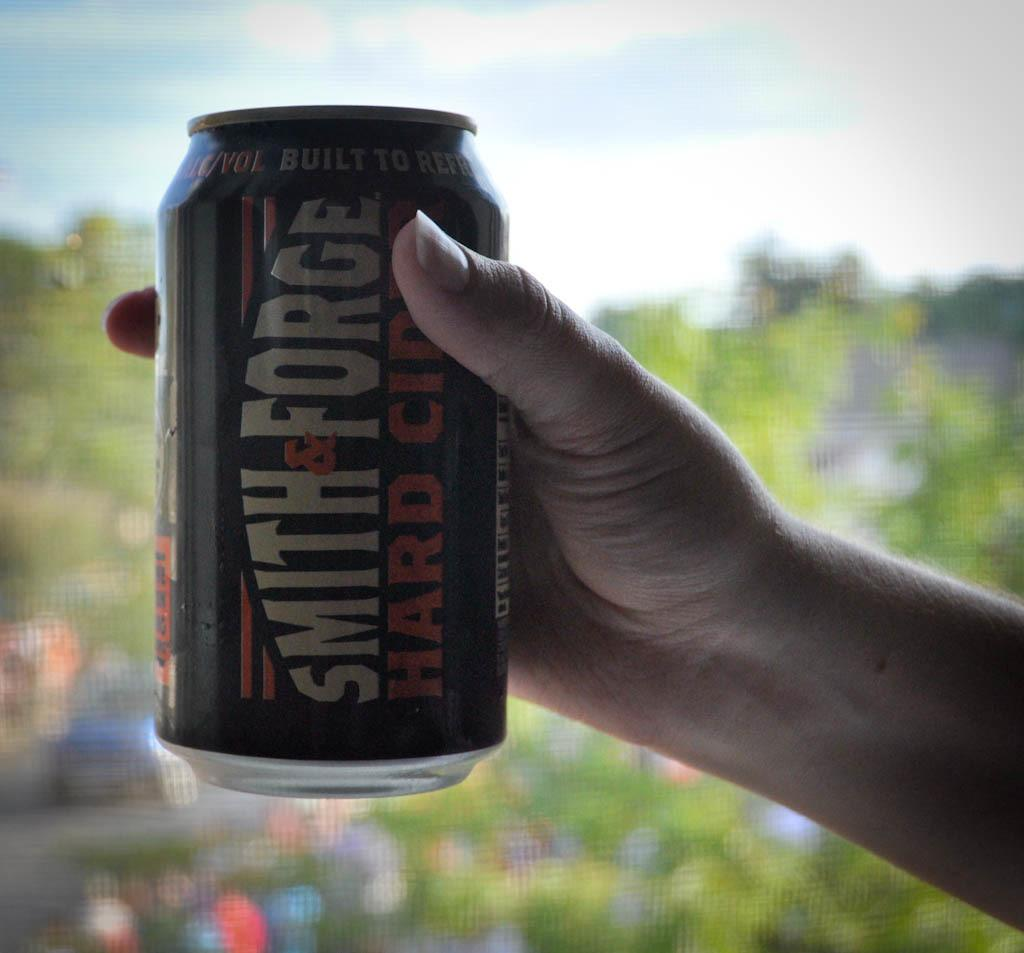<image>
Describe the image concisely. Someone is holding out a can of Smith & Forge hard cider. 